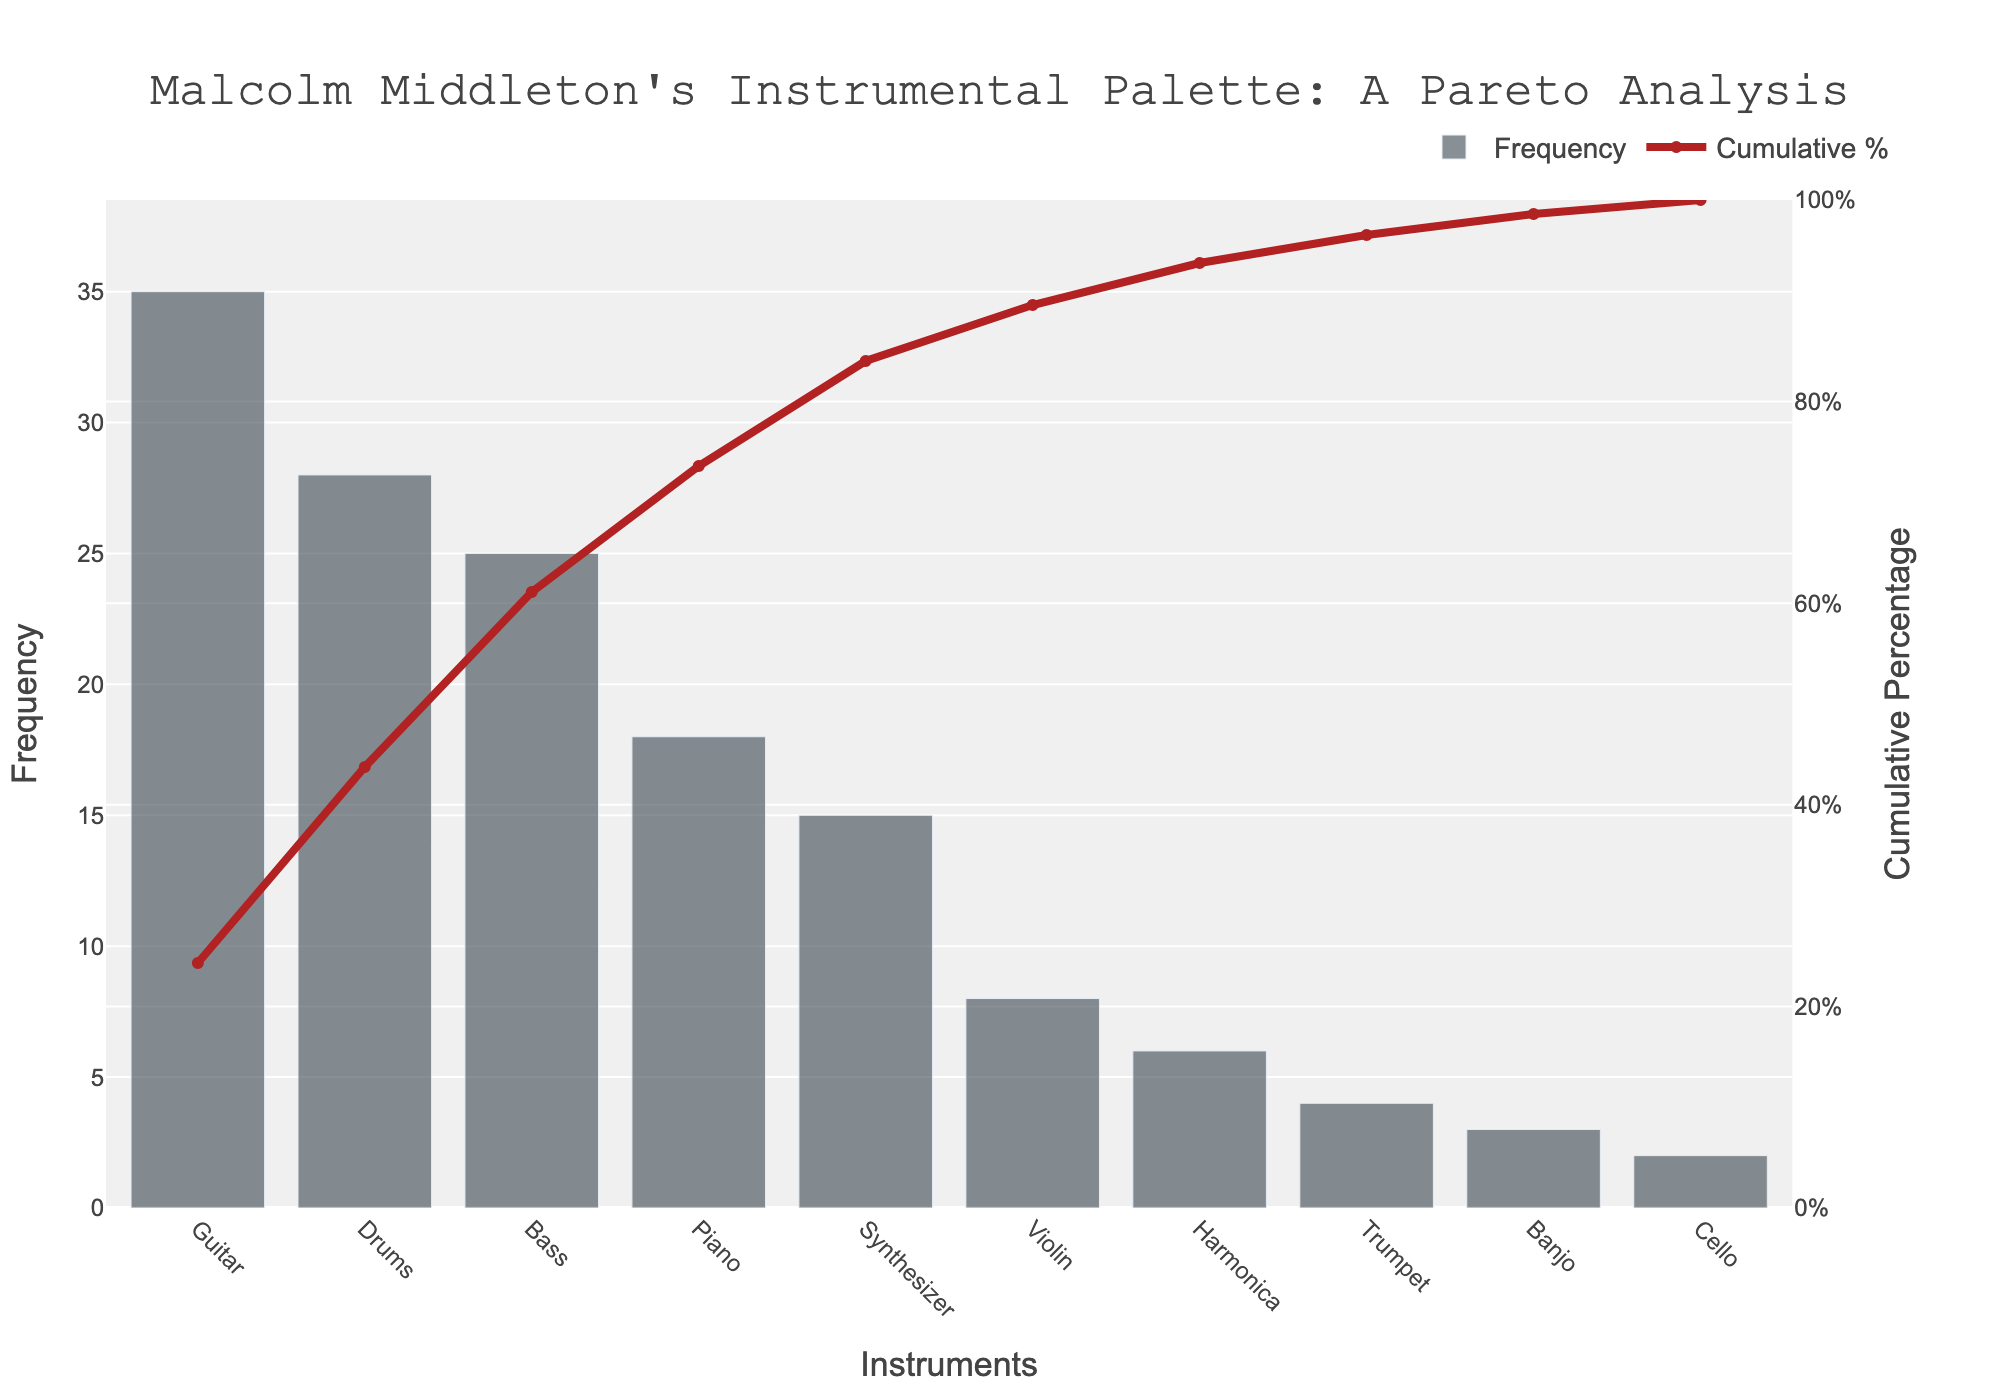Which instrument is most frequently used in Malcolm Middleton's albums? The instrument with the highest frequency in the Pareto chart is positioned at the far left. It is labeled "Guitar" with a frequency of 35.
Answer: Guitar What is the cumulative percentage for the top three instruments? To find the cumulative percentage for the top three instruments, sum their individual frequencies (Guitar: 35, Drums: 28, Bass: 25), which equals 88. Then, calculate the cumulative percentage as (88 / total frequency sum) * 100. The total frequency sum is 144. Therefore, (88/144) * 100 ≈ 61.1%.
Answer: 61.1% Which instrument contributes to exactly 50% of the total cumulative percentage? Start from the left of the Pareto chart and add the cumulative percentages of each instrument until you reach or exceed 50%. The cumulative percentage reaches just above 50% between Bass and Drums, meaning Bass contributes the 50% portion.
Answer: Bass How does the frequency of the synthesizer compare to the frequency of the piano? Locate the frequencies of both the synthesizer (15) and the piano (18) on the chart. Compare the two values to find that the synthesizer is used less frequently than the piano.
Answer: Less frequent What percentage of instruments is covered by the top five most frequently used instruments in Malcolm Middleton's albums? Sum the frequencies of the top five instruments (Guitar: 35, Drums: 28, Bass: 25, Piano: 18, Synthesizer: 15), which equals 121. The total frequency sum is 144. Calculate the percentage as (121/144) * 100 ≈ 84%.
Answer: 84% If Malcolm Middleton releases another album using 5 more songs featuring the Cello, how will its position on the chart change? The new frequency of the cello will be 7 (2 existing + 5 new). It would then have a higher frequency than the Banjo (3), and lower frequency than the Harmonica (6). So, it would move up one position above Banjo.
Answer: Above Banjo Which instrument has the smallest impact on the cumulative percentage in Malcolm Middleton’s albums? The instrument with the lowest frequency at the far right of the Pareto chart is the Cello with a frequency of 2, thus contributing the least to the cumulative percentage.
Answer: Cello What is the combined frequency of the least used three instruments in the chart? The least used three instruments are Banjo (3), Cello (2), and Trumpet (4). Summing these gives 3 + 2 + 4 = 9.
Answer: 9 